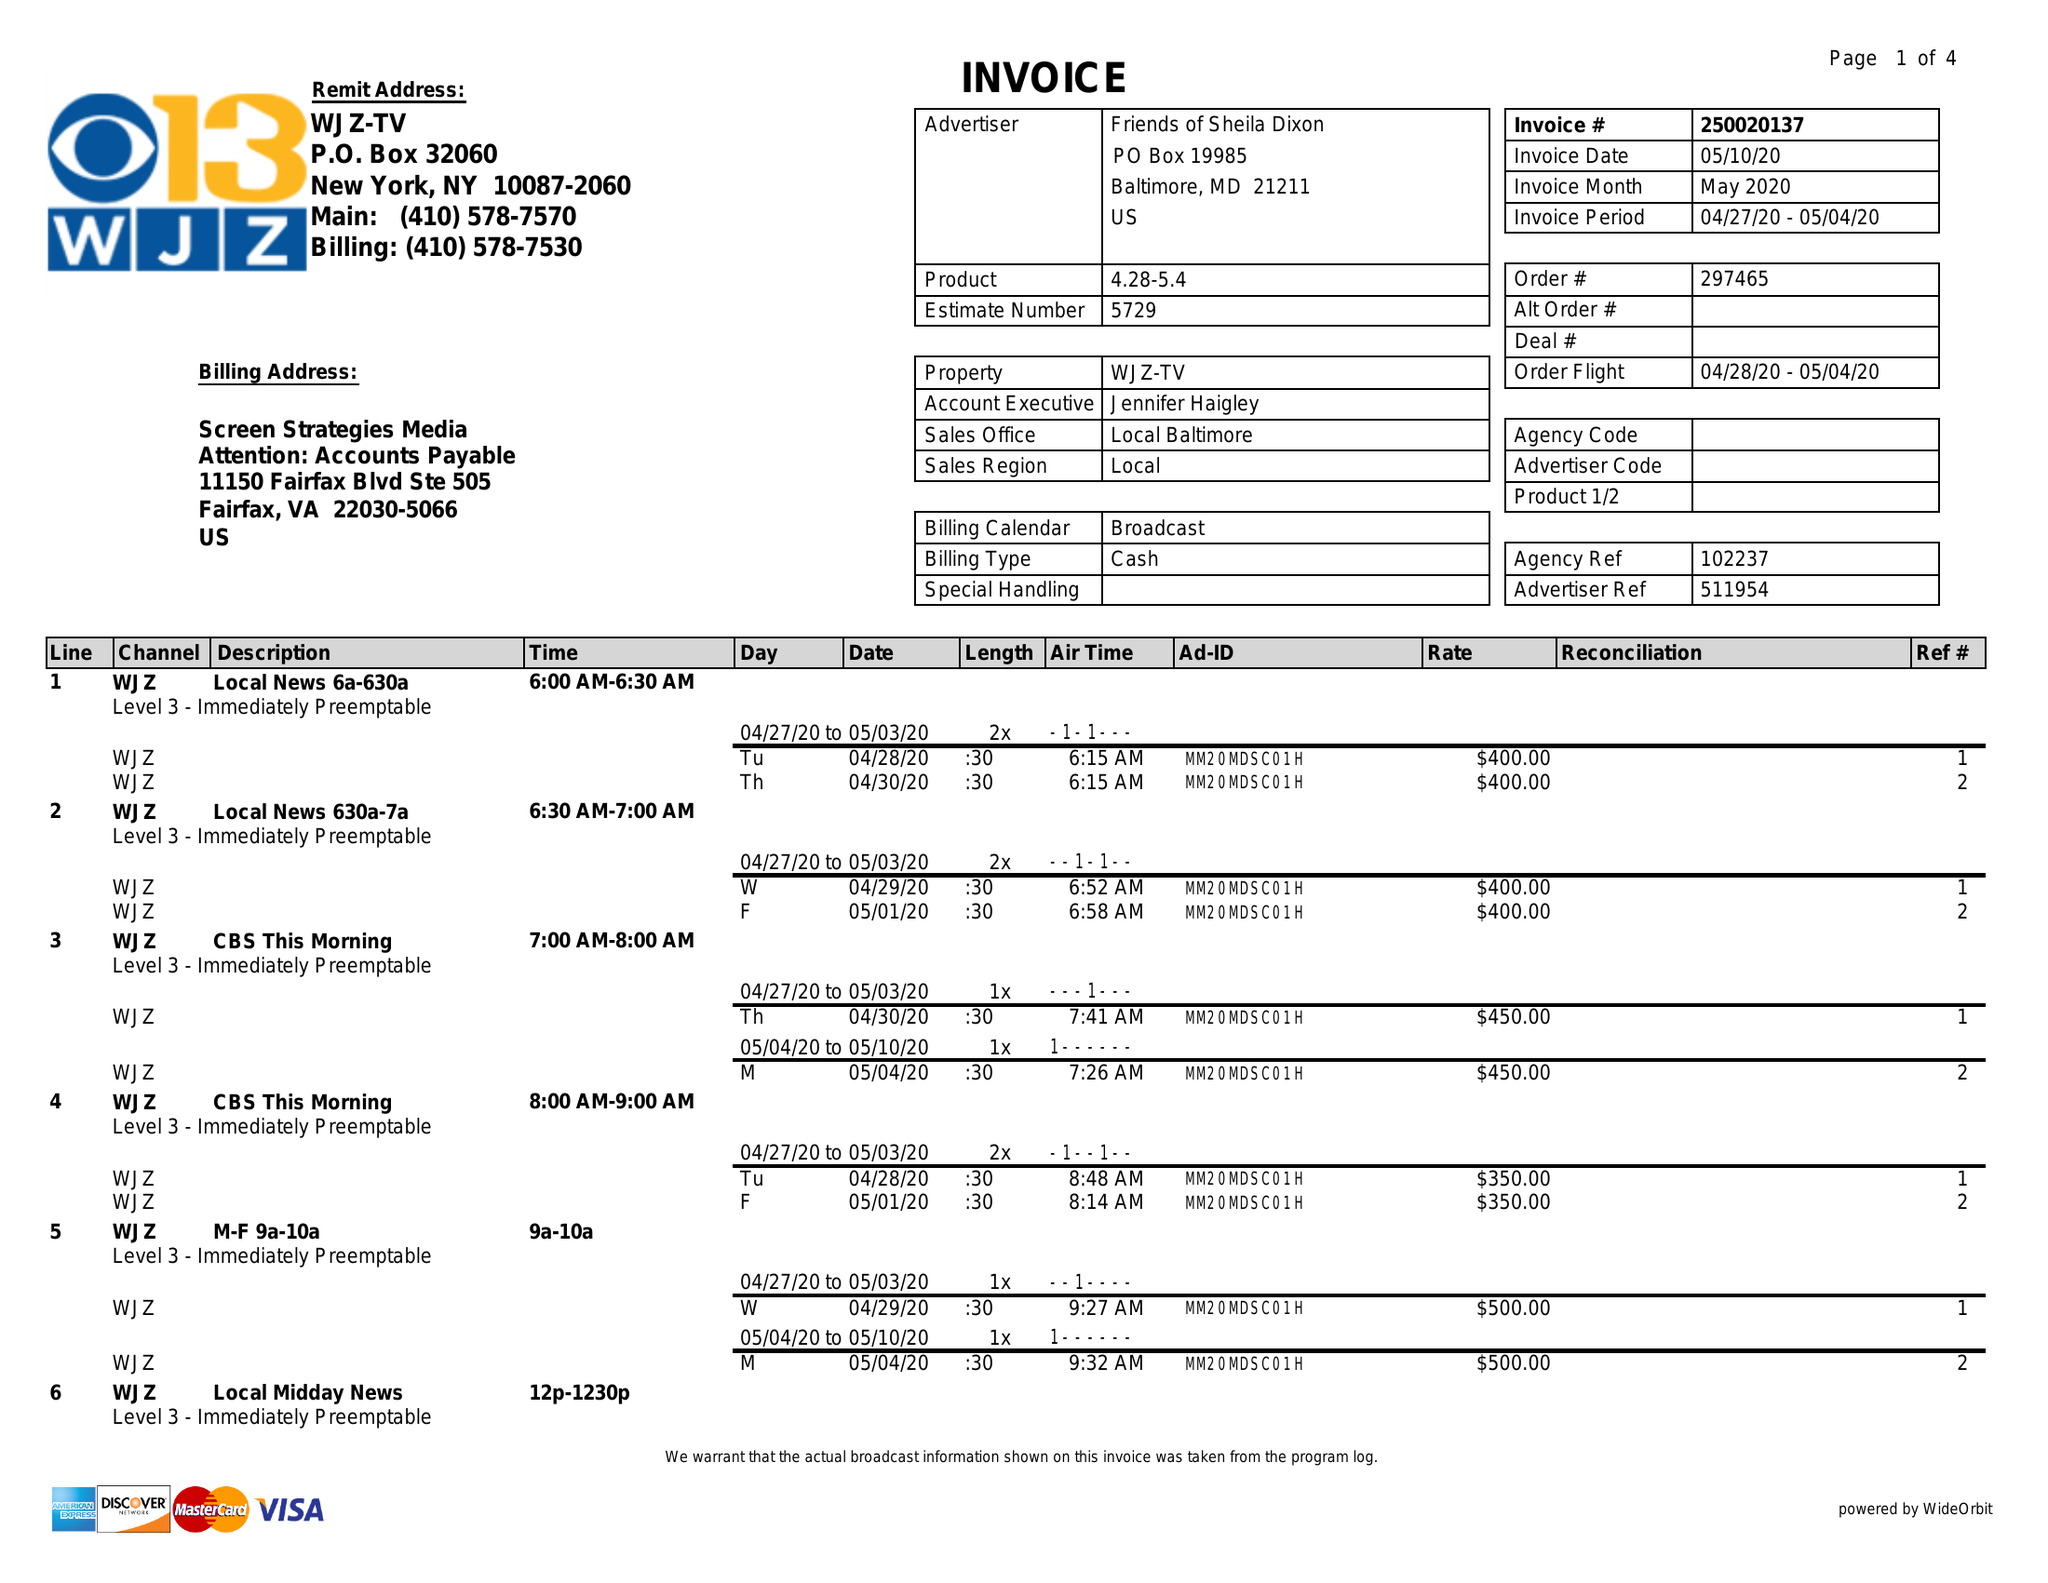What is the value for the gross_amount?
Answer the question using a single word or phrase. 15125.00 